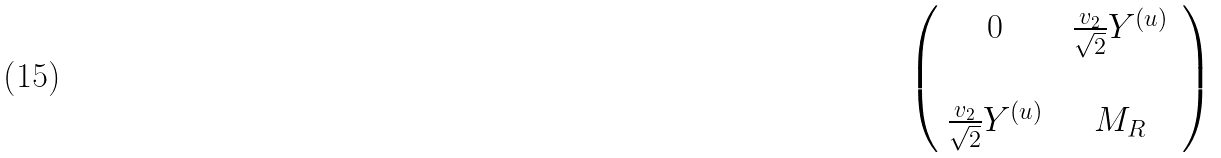Convert formula to latex. <formula><loc_0><loc_0><loc_500><loc_500>\left ( \begin{array} { c c } 0 \, & \, \frac { v _ { 2 } } { \sqrt { 2 } } Y ^ { ( u ) } \, \\ \, & \, \\ \frac { v _ { 2 } } { \sqrt { 2 } } Y ^ { ( u ) } \, & \, M _ { R } \, \end{array} \right )</formula> 